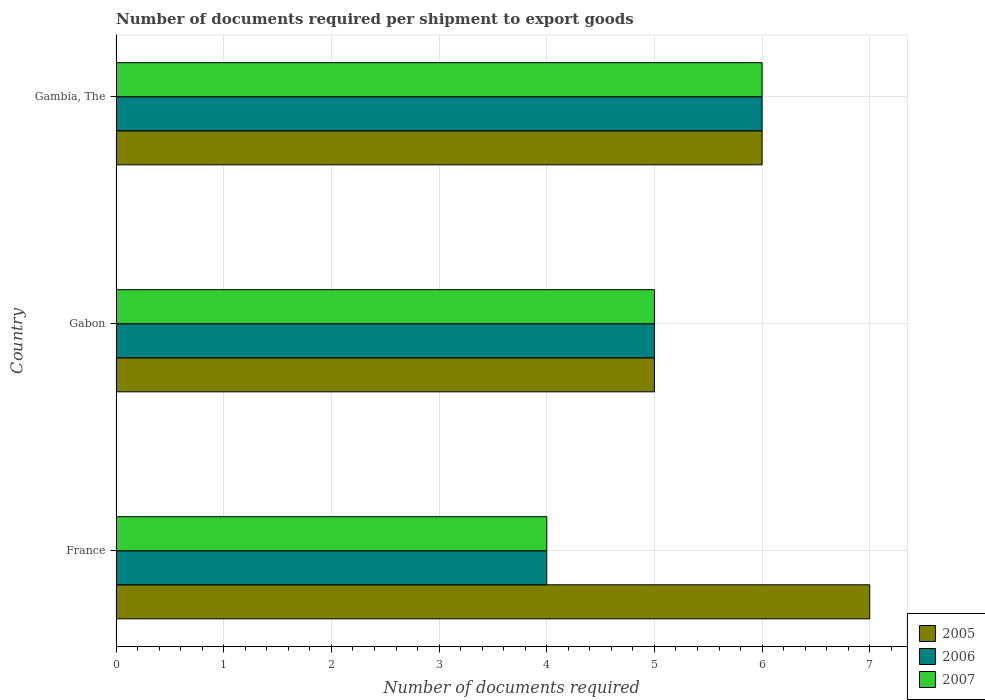How many groups of bars are there?
Keep it short and to the point. 3. Are the number of bars per tick equal to the number of legend labels?
Your answer should be very brief. Yes. What is the label of the 3rd group of bars from the top?
Provide a succinct answer. France. In how many cases, is the number of bars for a given country not equal to the number of legend labels?
Provide a succinct answer. 0. Across all countries, what is the minimum number of documents required per shipment to export goods in 2005?
Provide a succinct answer. 5. In which country was the number of documents required per shipment to export goods in 2005 maximum?
Provide a succinct answer. France. In which country was the number of documents required per shipment to export goods in 2005 minimum?
Your answer should be compact. Gabon. What is the difference between the number of documents required per shipment to export goods in 2007 in Gabon and that in Gambia, The?
Your answer should be very brief. -1. What is the difference between the number of documents required per shipment to export goods in 2007 in Gambia, The and the number of documents required per shipment to export goods in 2006 in Gabon?
Provide a succinct answer. 1. What is the difference between the number of documents required per shipment to export goods in 2005 and number of documents required per shipment to export goods in 2007 in Gambia, The?
Your answer should be compact. 0. What is the ratio of the number of documents required per shipment to export goods in 2006 in Gabon to that in Gambia, The?
Give a very brief answer. 0.83. What is the difference between the highest and the second highest number of documents required per shipment to export goods in 2007?
Offer a very short reply. 1. What is the difference between the highest and the lowest number of documents required per shipment to export goods in 2007?
Your answer should be compact. 2. What does the 3rd bar from the top in Gabon represents?
Keep it short and to the point. 2005. What does the 3rd bar from the bottom in Gabon represents?
Offer a very short reply. 2007. Is it the case that in every country, the sum of the number of documents required per shipment to export goods in 2007 and number of documents required per shipment to export goods in 2006 is greater than the number of documents required per shipment to export goods in 2005?
Offer a very short reply. Yes. Are all the bars in the graph horizontal?
Keep it short and to the point. Yes. How many countries are there in the graph?
Make the answer very short. 3. What is the difference between two consecutive major ticks on the X-axis?
Provide a short and direct response. 1. Does the graph contain any zero values?
Your answer should be very brief. No. How many legend labels are there?
Your response must be concise. 3. What is the title of the graph?
Keep it short and to the point. Number of documents required per shipment to export goods. What is the label or title of the X-axis?
Make the answer very short. Number of documents required. What is the Number of documents required in 2005 in France?
Offer a terse response. 7. What is the Number of documents required of 2006 in France?
Provide a short and direct response. 4. What is the Number of documents required of 2007 in France?
Offer a terse response. 4. What is the Number of documents required in 2005 in Gabon?
Ensure brevity in your answer.  5. What is the Number of documents required in 2006 in Gabon?
Keep it short and to the point. 5. What is the Number of documents required of 2007 in Gabon?
Keep it short and to the point. 5. What is the Number of documents required in 2006 in Gambia, The?
Your answer should be very brief. 6. What is the Number of documents required in 2007 in Gambia, The?
Provide a short and direct response. 6. Across all countries, what is the maximum Number of documents required of 2006?
Offer a terse response. 6. Across all countries, what is the minimum Number of documents required of 2006?
Make the answer very short. 4. What is the total Number of documents required in 2005 in the graph?
Your answer should be very brief. 18. What is the total Number of documents required in 2006 in the graph?
Provide a succinct answer. 15. What is the difference between the Number of documents required of 2005 in France and that in Gabon?
Your answer should be compact. 2. What is the difference between the Number of documents required in 2006 in France and that in Gabon?
Provide a succinct answer. -1. What is the difference between the Number of documents required in 2007 in France and that in Gabon?
Ensure brevity in your answer.  -1. What is the difference between the Number of documents required of 2006 in France and that in Gambia, The?
Provide a succinct answer. -2. What is the difference between the Number of documents required of 2007 in France and that in Gambia, The?
Offer a very short reply. -2. What is the difference between the Number of documents required of 2005 in Gabon and that in Gambia, The?
Give a very brief answer. -1. What is the difference between the Number of documents required in 2006 in Gabon and that in Gambia, The?
Your response must be concise. -1. What is the difference between the Number of documents required of 2007 in Gabon and that in Gambia, The?
Your response must be concise. -1. What is the difference between the Number of documents required in 2005 in France and the Number of documents required in 2006 in Gabon?
Your answer should be compact. 2. What is the difference between the Number of documents required in 2005 in France and the Number of documents required in 2007 in Gabon?
Offer a very short reply. 2. What is the difference between the Number of documents required in 2006 in France and the Number of documents required in 2007 in Gambia, The?
Make the answer very short. -2. What is the difference between the Number of documents required in 2005 in Gabon and the Number of documents required in 2006 in Gambia, The?
Your answer should be very brief. -1. What is the difference between the Number of documents required of 2005 in Gabon and the Number of documents required of 2007 in Gambia, The?
Ensure brevity in your answer.  -1. What is the difference between the Number of documents required of 2006 in Gabon and the Number of documents required of 2007 in Gambia, The?
Make the answer very short. -1. What is the average Number of documents required in 2005 per country?
Keep it short and to the point. 6. What is the average Number of documents required in 2007 per country?
Keep it short and to the point. 5. What is the difference between the Number of documents required in 2006 and Number of documents required in 2007 in France?
Give a very brief answer. 0. What is the difference between the Number of documents required in 2005 and Number of documents required in 2006 in Gabon?
Give a very brief answer. 0. What is the difference between the Number of documents required in 2005 and Number of documents required in 2007 in Gabon?
Make the answer very short. 0. What is the difference between the Number of documents required of 2005 and Number of documents required of 2006 in Gambia, The?
Provide a succinct answer. 0. What is the difference between the Number of documents required in 2005 and Number of documents required in 2007 in Gambia, The?
Give a very brief answer. 0. What is the difference between the Number of documents required of 2006 and Number of documents required of 2007 in Gambia, The?
Keep it short and to the point. 0. What is the ratio of the Number of documents required of 2006 in France to that in Gabon?
Offer a terse response. 0.8. What is the ratio of the Number of documents required of 2005 in France to that in Gambia, The?
Ensure brevity in your answer.  1.17. What is the difference between the highest and the second highest Number of documents required in 2005?
Make the answer very short. 1. 